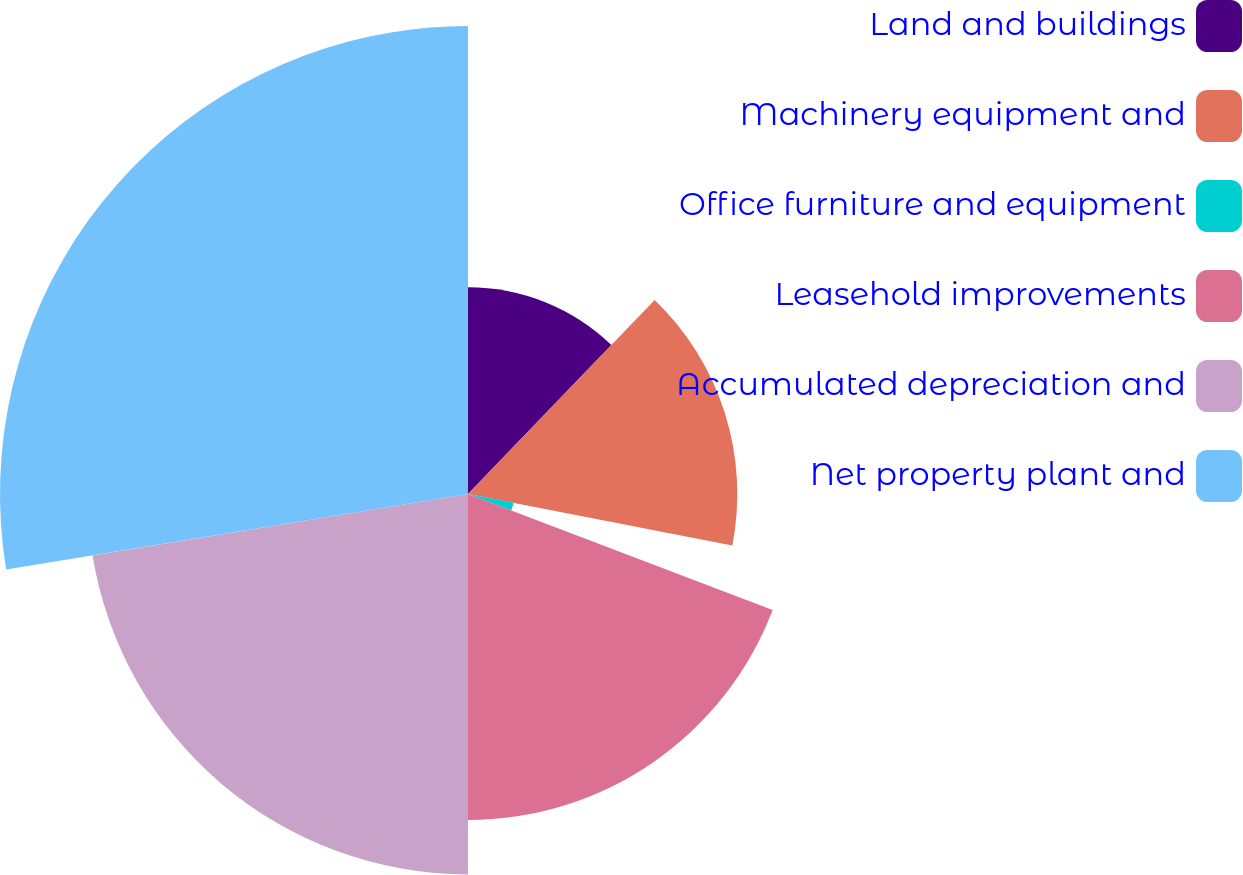Convert chart. <chart><loc_0><loc_0><loc_500><loc_500><pie_chart><fcel>Land and buildings<fcel>Machinery equipment and<fcel>Office furniture and equipment<fcel>Leasehold improvements<fcel>Accumulated depreciation and<fcel>Net property plant and<nl><fcel>12.19%<fcel>15.87%<fcel>2.73%<fcel>19.21%<fcel>22.42%<fcel>27.58%<nl></chart> 